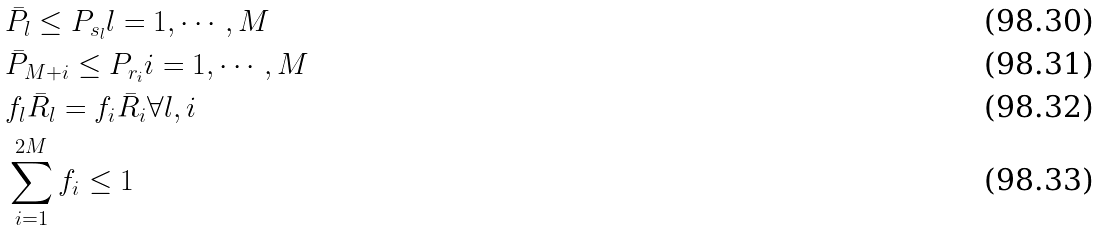Convert formula to latex. <formula><loc_0><loc_0><loc_500><loc_500>& \bar { P } _ { l } \leq P _ { s _ { l } } l = 1 , \cdots , M \\ & \bar { P } _ { M + i } \leq P _ { r _ { i } } i = 1 , \cdots , M \\ & f _ { l } \bar { R } _ { l } = f _ { i } \bar { R } _ { i } \forall l , i \\ & \sum _ { i = 1 } ^ { 2 M } f _ { i } \leq 1</formula> 